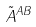<formula> <loc_0><loc_0><loc_500><loc_500>\tilde { A } ^ { A B }</formula> 